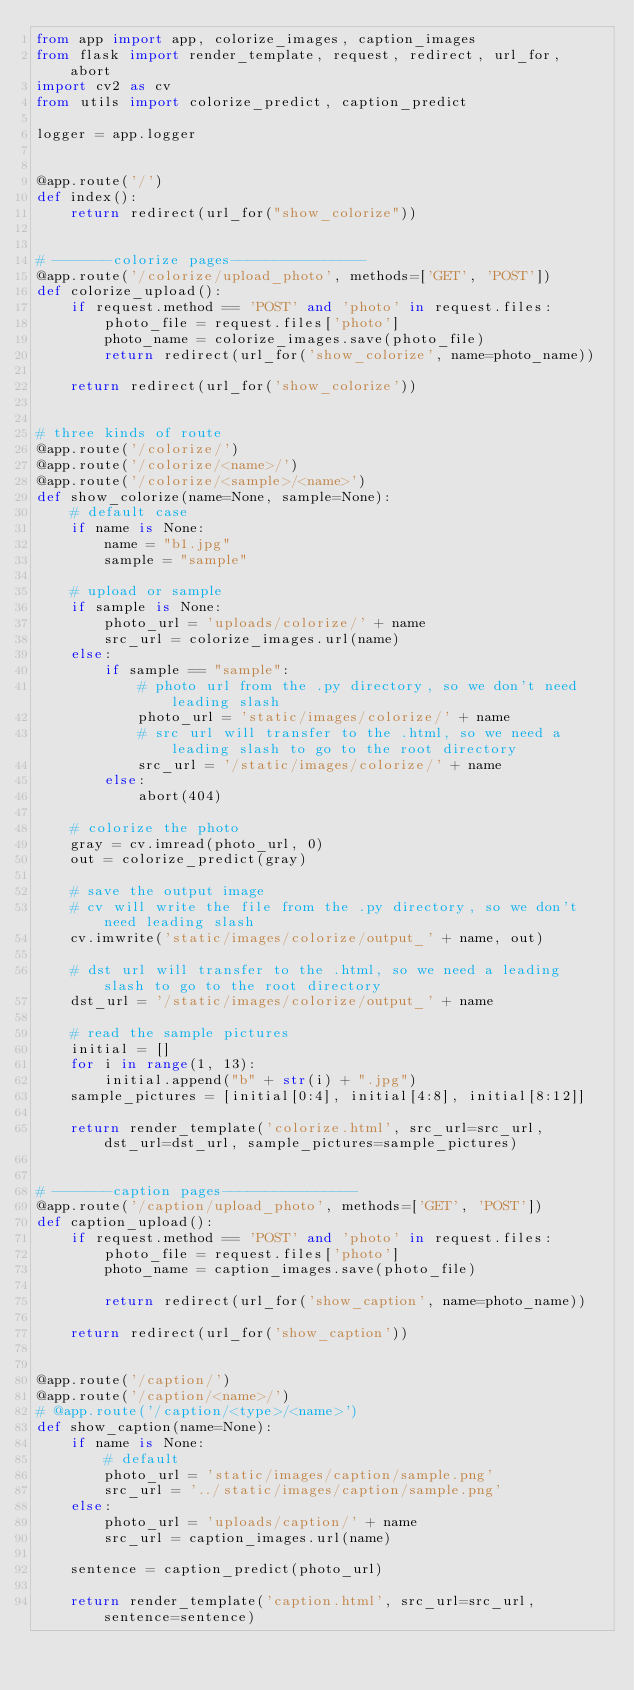<code> <loc_0><loc_0><loc_500><loc_500><_Python_>from app import app, colorize_images, caption_images
from flask import render_template, request, redirect, url_for, abort
import cv2 as cv
from utils import colorize_predict, caption_predict

logger = app.logger


@app.route('/')
def index():
    return redirect(url_for("show_colorize"))


# -------colorize pages----------------
@app.route('/colorize/upload_photo', methods=['GET', 'POST'])
def colorize_upload():
    if request.method == 'POST' and 'photo' in request.files:
        photo_file = request.files['photo']
        photo_name = colorize_images.save(photo_file)
        return redirect(url_for('show_colorize', name=photo_name))

    return redirect(url_for('show_colorize'))


# three kinds of route
@app.route('/colorize/')
@app.route('/colorize/<name>/')
@app.route('/colorize/<sample>/<name>')
def show_colorize(name=None, sample=None):
    # default case
    if name is None:
        name = "b1.jpg"
        sample = "sample"

    # upload or sample
    if sample is None:
        photo_url = 'uploads/colorize/' + name
        src_url = colorize_images.url(name)
    else:
        if sample == "sample":
            # photo url from the .py directory, so we don't need leading slash
            photo_url = 'static/images/colorize/' + name
            # src url will transfer to the .html, so we need a leading slash to go to the root directory
            src_url = '/static/images/colorize/' + name
        else:
            abort(404)

    # colorize the photo
    gray = cv.imread(photo_url, 0)
    out = colorize_predict(gray)

    # save the output image
    # cv will write the file from the .py directory, so we don't need leading slash
    cv.imwrite('static/images/colorize/output_' + name, out)

    # dst url will transfer to the .html, so we need a leading slash to go to the root directory
    dst_url = '/static/images/colorize/output_' + name

    # read the sample pictures
    initial = []
    for i in range(1, 13):
        initial.append("b" + str(i) + ".jpg")
    sample_pictures = [initial[0:4], initial[4:8], initial[8:12]]

    return render_template('colorize.html', src_url=src_url, dst_url=dst_url, sample_pictures=sample_pictures)


# -------caption pages----------------
@app.route('/caption/upload_photo', methods=['GET', 'POST'])
def caption_upload():
    if request.method == 'POST' and 'photo' in request.files:
        photo_file = request.files['photo']
        photo_name = caption_images.save(photo_file)

        return redirect(url_for('show_caption', name=photo_name))

    return redirect(url_for('show_caption'))


@app.route('/caption/')
@app.route('/caption/<name>/')
# @app.route('/caption/<type>/<name>')
def show_caption(name=None):
    if name is None:
        # default
        photo_url = 'static/images/caption/sample.png'
        src_url = '../static/images/caption/sample.png'
    else:
        photo_url = 'uploads/caption/' + name
        src_url = caption_images.url(name)

    sentence = caption_predict(photo_url)

    return render_template('caption.html', src_url=src_url, sentence=sentence)
</code> 